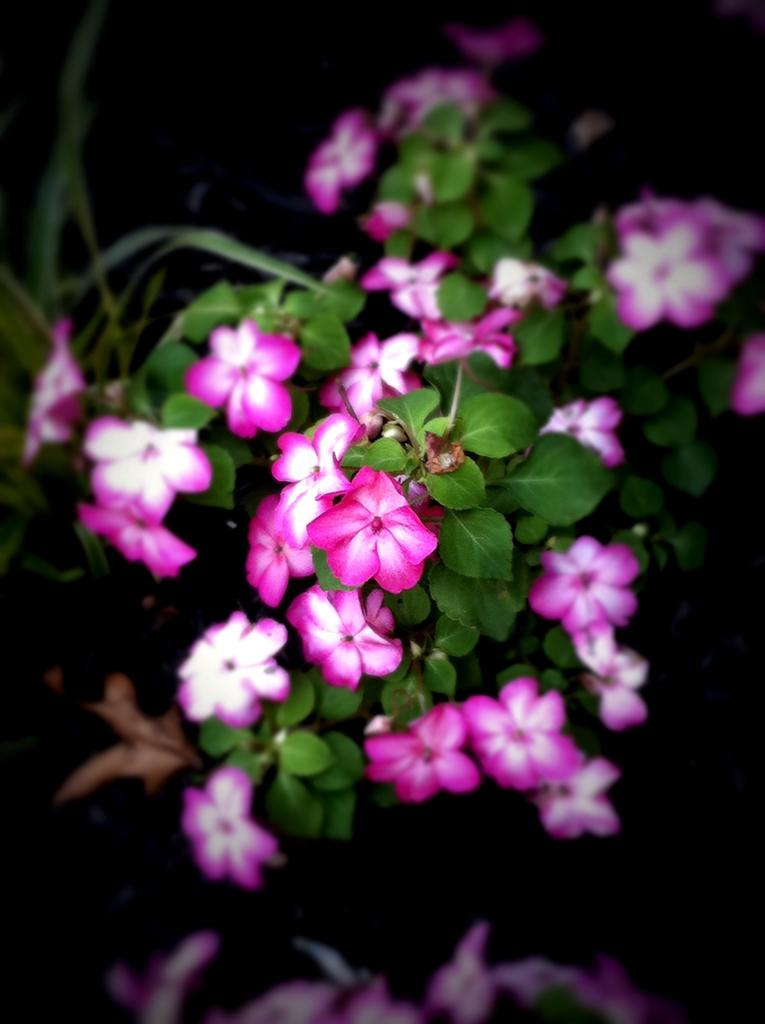What type of plant is shown in the image? The image shows a plant with many flowers. Can you describe the leaves on the plant? The leaves are on the right side of the plant. How does the alley feel about the friend in the image? There is no alley or friend present in the image; it only features a plant with flowers and leaves. 